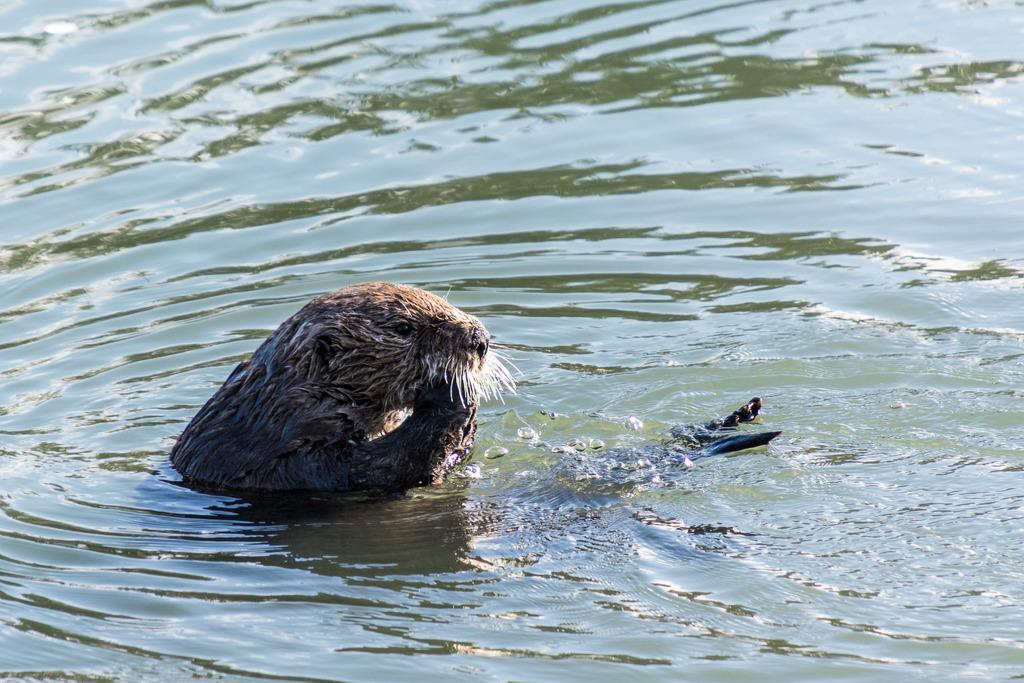What is the main subject of the image? There is an animal in the water in the image. What type of pollution can be seen in the image? There is no pollution visible in the image; it only features an animal in the water. What advice would the animal's dad give in the image? There is no dad or advice present in the image, as it only features an animal in the water. 